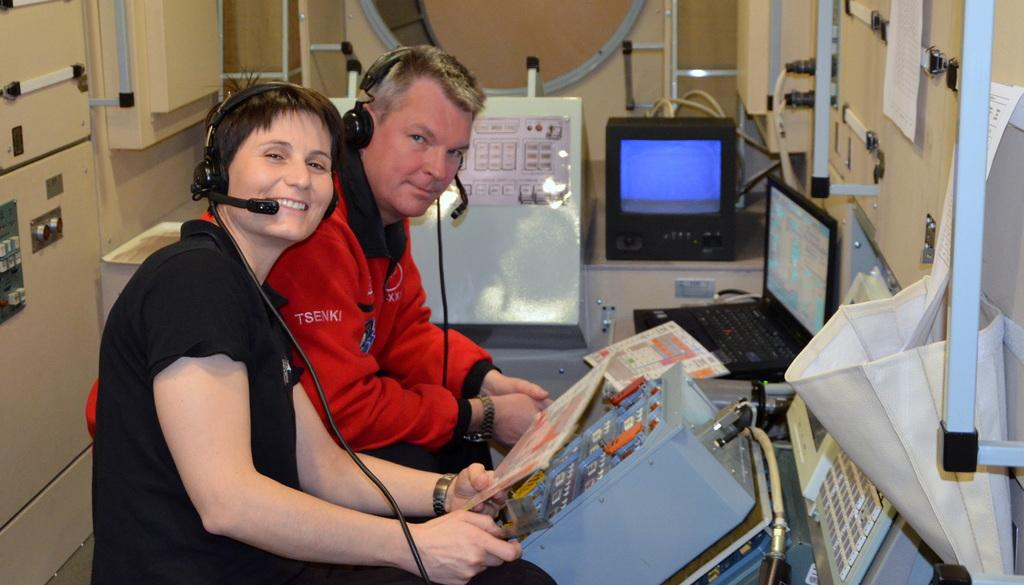How many people are present in the image? There are two people sitting in the image. What are the people wearing? The people are wearing headphones. What objects can be seen in the image besides the people? There are devices visible in the image. What is on the left side of the image? There is a wall on the left side of the image. What items are hanging on the wall? There is a bag and papers on the wall. Can you see a tiger walking past the people in the image? No, there is no tiger present in the image. What type of sticks are being used by the people in the image? There are no sticks visible in the image; the people are wearing headphones and using devices. 